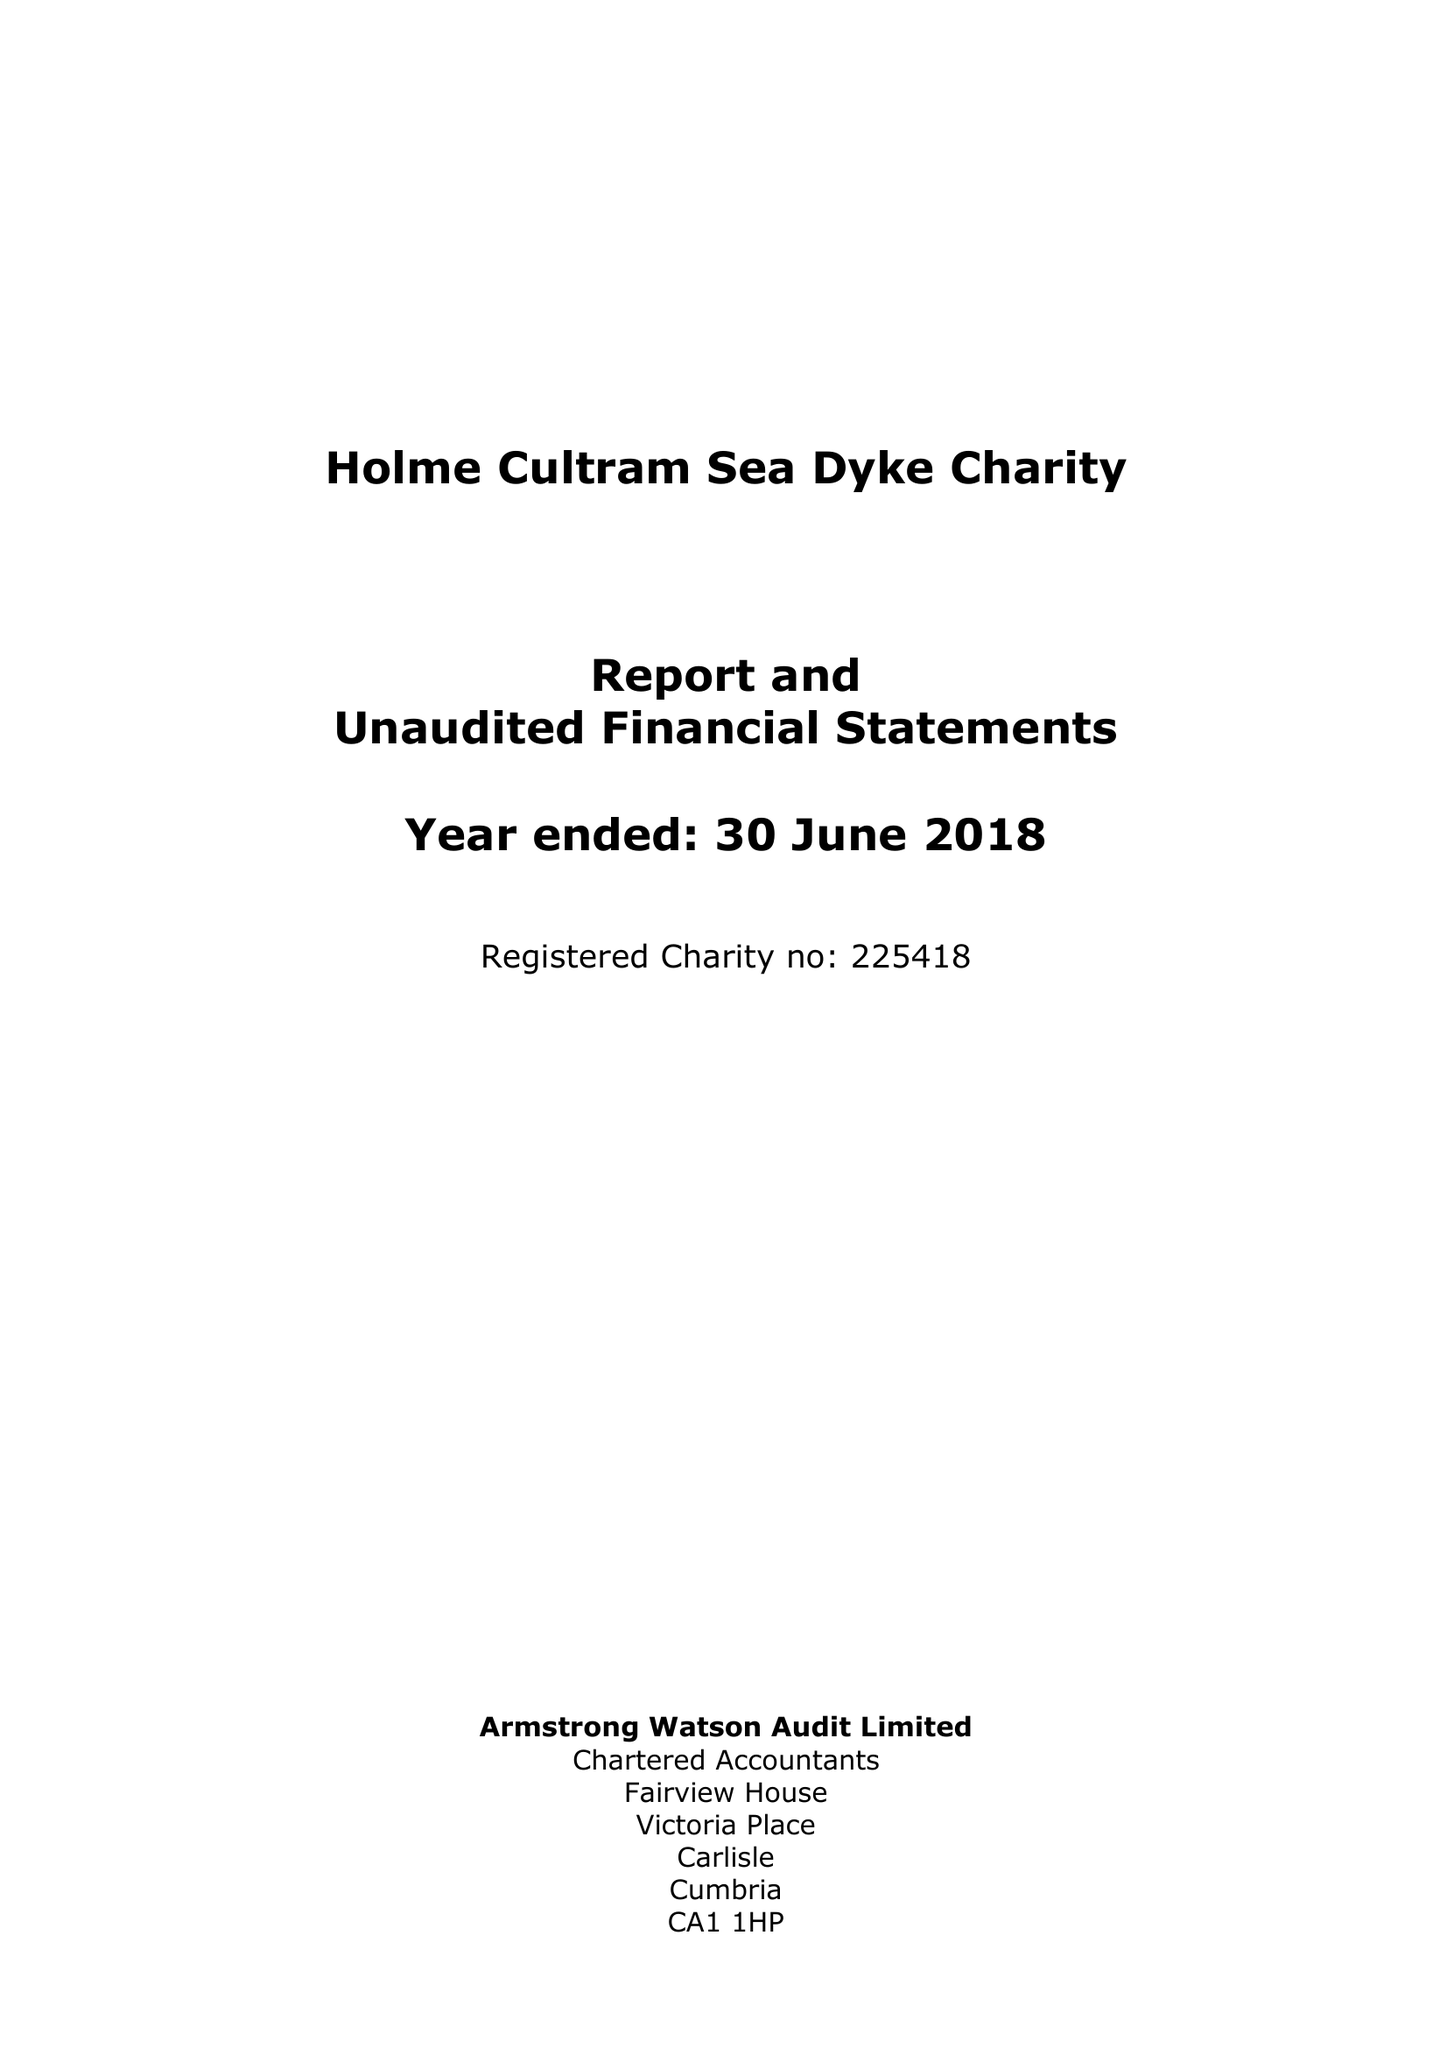What is the value for the charity_number?
Answer the question using a single word or phrase. 225418 